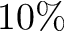Convert formula to latex. <formula><loc_0><loc_0><loc_500><loc_500>1 0 \%</formula> 